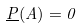<formula> <loc_0><loc_0><loc_500><loc_500>\underline { P } ( A ) = 0</formula> 